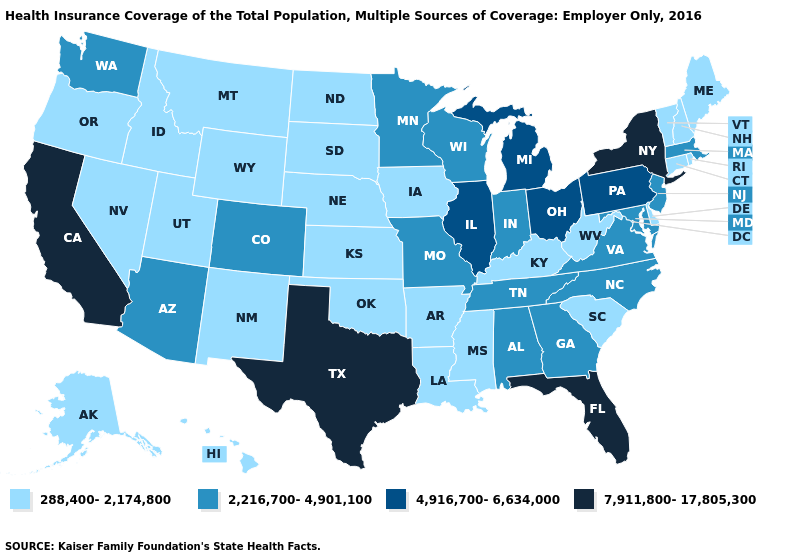Does the first symbol in the legend represent the smallest category?
Write a very short answer. Yes. Does Utah have the lowest value in the USA?
Quick response, please. Yes. Does Maine have the lowest value in the USA?
Quick response, please. Yes. What is the value of Tennessee?
Write a very short answer. 2,216,700-4,901,100. What is the highest value in states that border New Hampshire?
Be succinct. 2,216,700-4,901,100. How many symbols are there in the legend?
Write a very short answer. 4. Among the states that border Wyoming , which have the lowest value?
Give a very brief answer. Idaho, Montana, Nebraska, South Dakota, Utah. What is the highest value in the MidWest ?
Keep it brief. 4,916,700-6,634,000. Does the map have missing data?
Short answer required. No. What is the highest value in the USA?
Write a very short answer. 7,911,800-17,805,300. Name the states that have a value in the range 2,216,700-4,901,100?
Answer briefly. Alabama, Arizona, Colorado, Georgia, Indiana, Maryland, Massachusetts, Minnesota, Missouri, New Jersey, North Carolina, Tennessee, Virginia, Washington, Wisconsin. Does Kentucky have the same value as Michigan?
Quick response, please. No. Name the states that have a value in the range 7,911,800-17,805,300?
Write a very short answer. California, Florida, New York, Texas. What is the value of California?
Be succinct. 7,911,800-17,805,300. Does the map have missing data?
Quick response, please. No. 